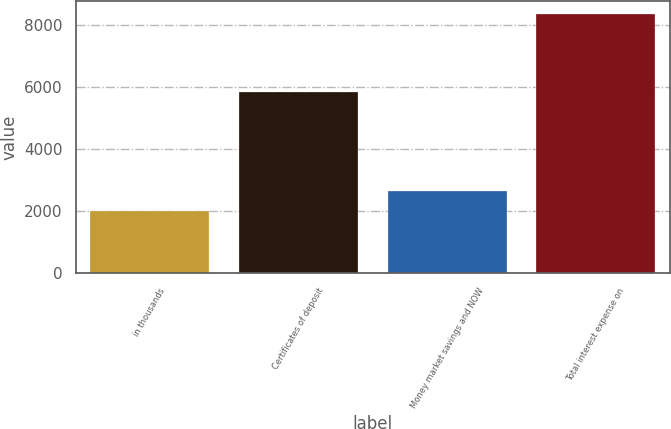Convert chart to OTSL. <chart><loc_0><loc_0><loc_500><loc_500><bar_chart><fcel>in thousands<fcel>Certificates of deposit<fcel>Money market savings and NOW<fcel>Total interest expense on<nl><fcel>2015<fcel>5839<fcel>2651.7<fcel>8382<nl></chart> 